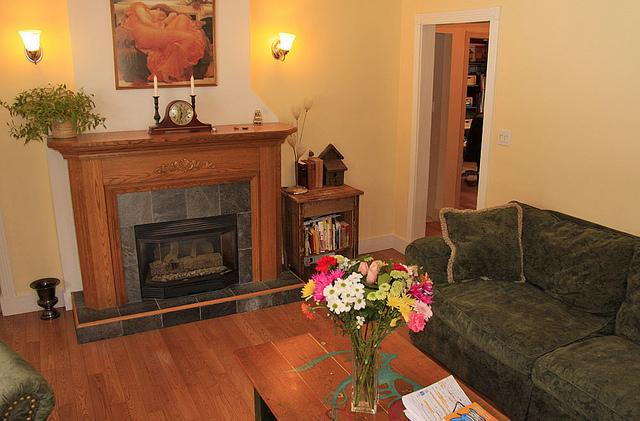How many portraits are hung above the fireplace mantle? one 